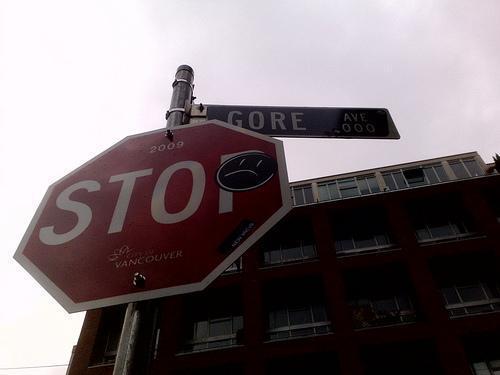How many people are in the picture?
Give a very brief answer. 0. 